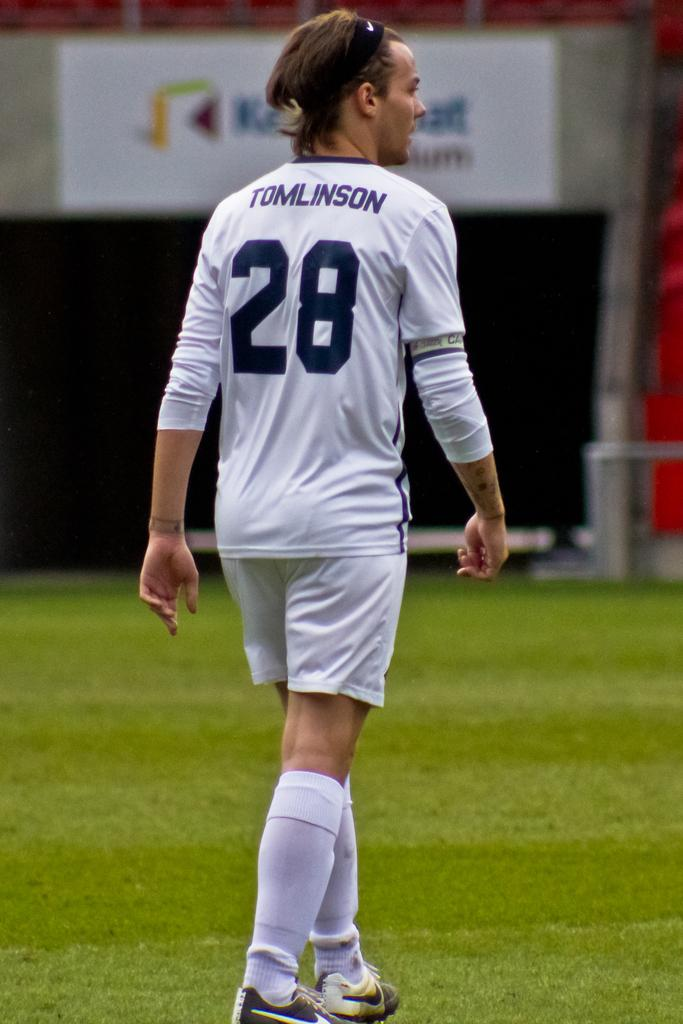<image>
Summarize the visual content of the image. number 28 Tomlinson is walking on the field 